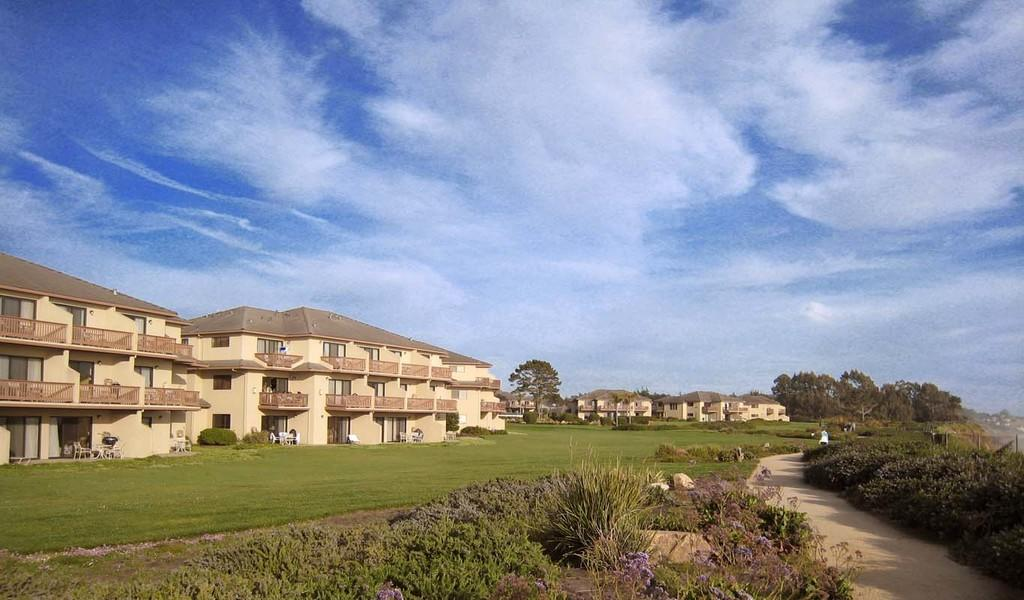What type of structures can be seen in the image? There are buildings in the image. What type of vegetation is present in the image? There are trees and bushes in the image. What is located at the bottom of the image? There is a pathway and grass at the bottom of the image. What can be seen in the background of the image? The sky is visible in the background of the image. Where is the zipper located on the trees in the image? There are no zippers present on the trees in the image. What type of system is responsible for the end of the pathway in the image? The image does not show any system related to the end of the pathway, nor does it indicate that the pathway has an end. 